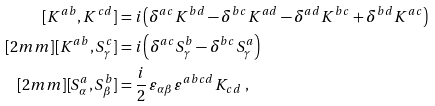Convert formula to latex. <formula><loc_0><loc_0><loc_500><loc_500>[ K ^ { a b } , K ^ { c d } ] & = i \left ( \delta ^ { a c } K ^ { b d } - \delta ^ { b c } K ^ { a d } - \delta ^ { a d } K ^ { b c } + \delta ^ { b d } K ^ { a c } \right ) \\ [ 2 m m ] [ K ^ { a b } , S ^ { c } _ { \gamma } ] & = i \left ( \delta ^ { a c } S ^ { b } _ { \gamma } - \delta ^ { b c } S ^ { a } _ { \gamma } \right ) \\ [ 2 m m ] [ S ^ { a } _ { \alpha } , S ^ { b } _ { \beta } ] & = \frac { i } { 2 } \, \varepsilon _ { \alpha \beta } \, \varepsilon ^ { a b c d } K _ { c d } \ ,</formula> 